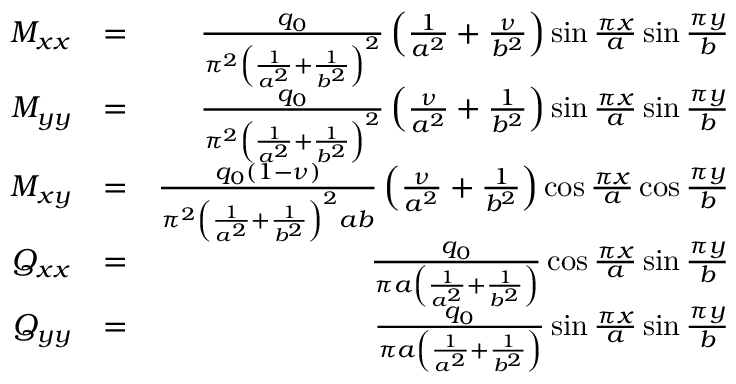Convert formula to latex. <formula><loc_0><loc_0><loc_500><loc_500>\begin{array} { r l r } { M _ { x x } } & { = } & { \frac { q _ { 0 } } { \pi ^ { 2 } \left ( \frac { 1 } { a ^ { 2 } } + \frac { 1 } { b ^ { 2 } } \right ) ^ { 2 } } \left ( \frac { 1 } { a ^ { 2 } } + \frac { \nu } { b ^ { 2 } } \right ) \sin \frac { \pi x } { a } \sin \frac { \pi y } { b } } \\ { M _ { y y } } & { = } & { \frac { q _ { 0 } } { \pi ^ { 2 } \left ( \frac { 1 } { a ^ { 2 } } + \frac { 1 } { b ^ { 2 } } \right ) ^ { 2 } } \left ( \frac { \nu } { a ^ { 2 } } + \frac { 1 } { b ^ { 2 } } \right ) \sin \frac { \pi x } { a } \sin \frac { \pi y } { b } } \\ { M _ { x y } } & { = } & { \frac { q _ { 0 } ( 1 - \nu ) } { \pi ^ { 2 } \left ( \frac { 1 } { a ^ { 2 } } + \frac { 1 } { b ^ { 2 } } \right ) ^ { 2 } a b } \left ( \frac { \nu } { a ^ { 2 } } + \frac { 1 } { b ^ { 2 } } \right ) \cos \frac { \pi x } { a } \cos \frac { \pi y } { b } } \\ { Q _ { x x } } & { = } & { \frac { q _ { 0 } } { \pi a \left ( \frac { 1 } { a ^ { 2 } } + \frac { 1 } { b ^ { 2 } } \right ) } \cos \frac { \pi x } { a } \sin \frac { \pi y } { b } } \\ { Q _ { y y } } & { = } & { \frac { q _ { 0 } } { \pi a \left ( \frac { 1 } { a ^ { 2 } } + \frac { 1 } { b ^ { 2 } } \right ) } \sin \frac { \pi x } { a } \sin \frac { \pi y } { b } } \end{array}</formula> 